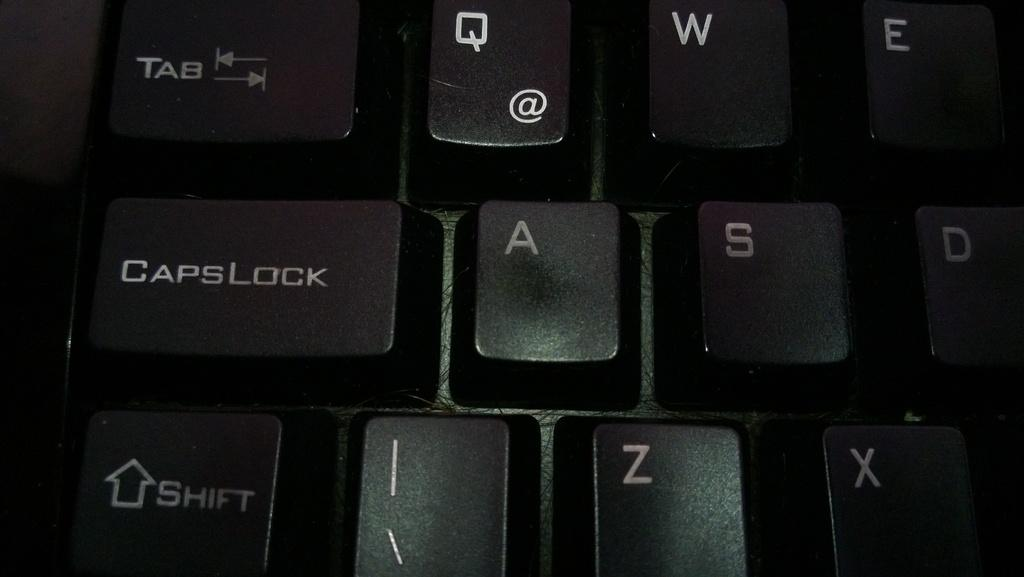<image>
Share a concise interpretation of the image provided. keyboard keys called 'tab, capslock, and shift' and a few letters 